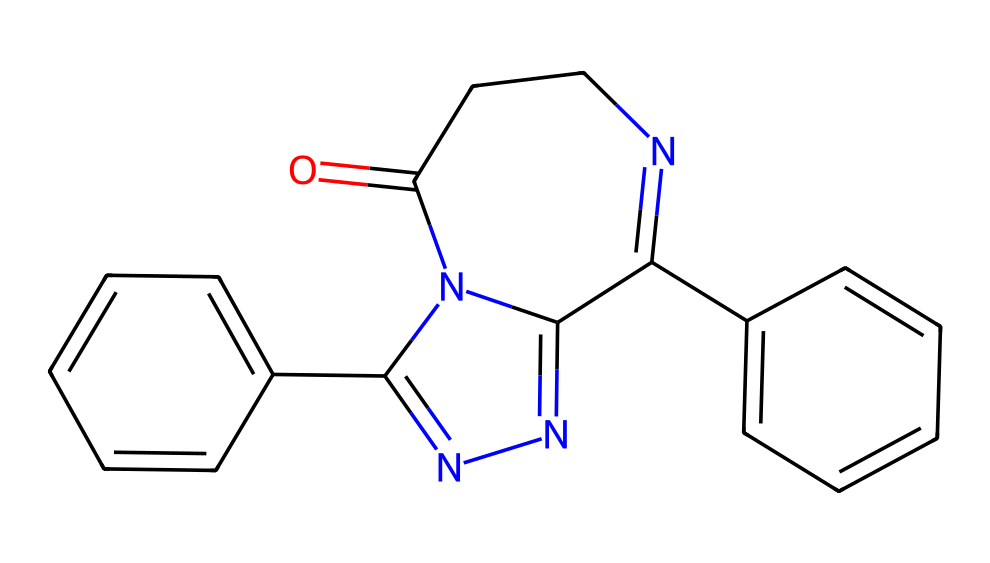What is the total number of rings in this chemical structure? The given SMILES represents a compound that contains two distinct ring structures. By analyzing the cyclic parts of the SMILES, we can identify these rings, noting connections where atoms form closed loops. Thus, we count each unique ring formed.
Answer: two What type of drug is indicated by this chemical structure? The SMILES shows a structure typically associated with benzodiazepines, which are a well-known class of anxiolytics and hypnotics. The presence of benzene rings and nitrogen-containing domains is characteristic of benzodiazepine compounds.
Answer: benzodiazepine How many nitrogen atoms are present in this chemical? In the provided SMILES, we can identify nitrogen atoms by looking for the symbols 'N'. A systematic visual check indicates there are three nitrogen atoms present in the compound's structure.
Answer: three Does this chemical structure have any functional groups? The structure contains a fused ring system, and by analyzing the SMILES, we note the presence of a carbonyl group (=O) and amine groups (-N), which function as important functional groups in medicinal chemistry.
Answer: yes What is the significance of the aromatic rings in this drug? The presence of aromatic rings contributes to the lipophilicity and overall pharmacological profile of benzodiazepines, enhancing their ability to cross the blood-brain barrier and exert effects on neurotransmitter systems.
Answer: pharmacological profile 